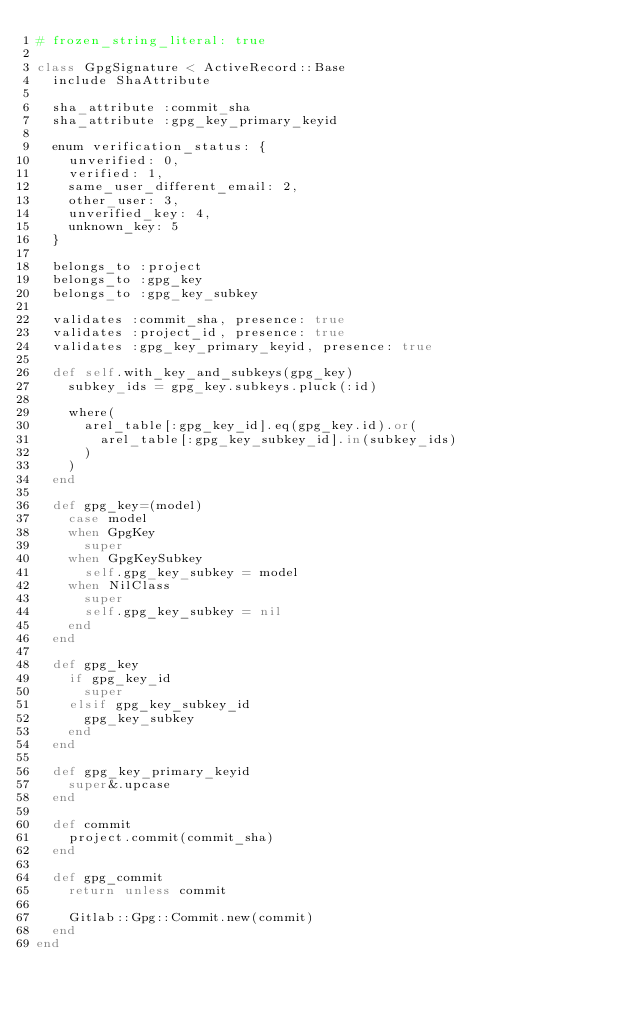<code> <loc_0><loc_0><loc_500><loc_500><_Ruby_># frozen_string_literal: true

class GpgSignature < ActiveRecord::Base
  include ShaAttribute

  sha_attribute :commit_sha
  sha_attribute :gpg_key_primary_keyid

  enum verification_status: {
    unverified: 0,
    verified: 1,
    same_user_different_email: 2,
    other_user: 3,
    unverified_key: 4,
    unknown_key: 5
  }

  belongs_to :project
  belongs_to :gpg_key
  belongs_to :gpg_key_subkey

  validates :commit_sha, presence: true
  validates :project_id, presence: true
  validates :gpg_key_primary_keyid, presence: true

  def self.with_key_and_subkeys(gpg_key)
    subkey_ids = gpg_key.subkeys.pluck(:id)

    where(
      arel_table[:gpg_key_id].eq(gpg_key.id).or(
        arel_table[:gpg_key_subkey_id].in(subkey_ids)
      )
    )
  end

  def gpg_key=(model)
    case model
    when GpgKey
      super
    when GpgKeySubkey
      self.gpg_key_subkey = model
    when NilClass
      super
      self.gpg_key_subkey = nil
    end
  end

  def gpg_key
    if gpg_key_id
      super
    elsif gpg_key_subkey_id
      gpg_key_subkey
    end
  end

  def gpg_key_primary_keyid
    super&.upcase
  end

  def commit
    project.commit(commit_sha)
  end

  def gpg_commit
    return unless commit

    Gitlab::Gpg::Commit.new(commit)
  end
end
</code> 